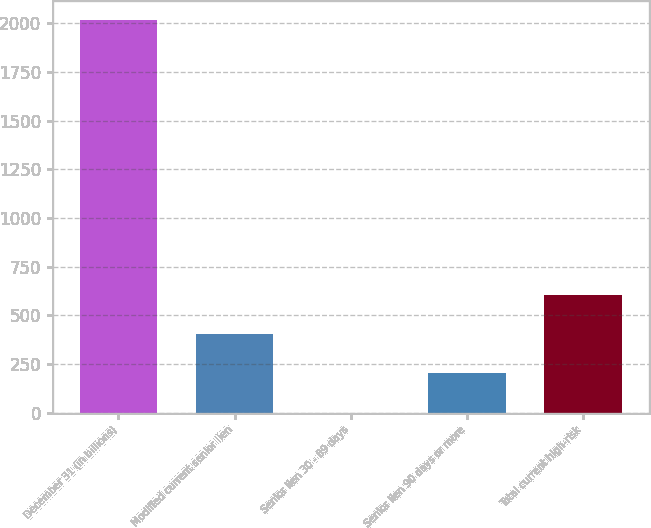Convert chart to OTSL. <chart><loc_0><loc_0><loc_500><loc_500><bar_chart><fcel>December 31 (in billions)<fcel>Modified current senior lien<fcel>Senior lien 30 - 89 days<fcel>Senior lien 90 days or more<fcel>Total current high-risk<nl><fcel>2015<fcel>403.32<fcel>0.4<fcel>201.86<fcel>604.78<nl></chart> 